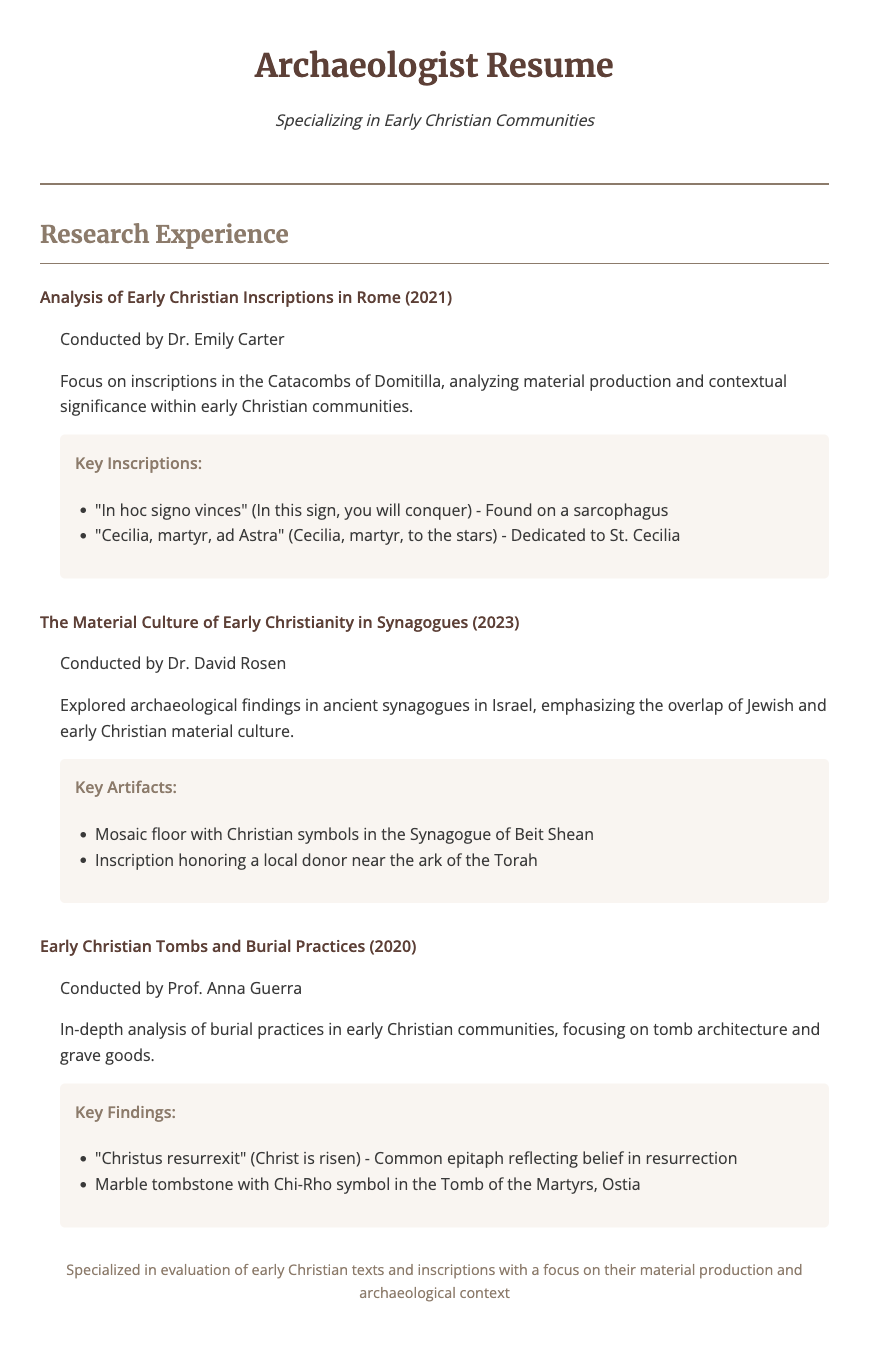what is the title of the research conducted in 2021? The title of the research is mentioned in the section on research experience, specifically stating "Analysis of Early Christian Inscriptions in Rome".
Answer: Analysis of Early Christian Inscriptions in Rome who conducted the research on the material culture of early Christianity in synagogues? The research on the material culture of early Christianity in synagogues was conducted by Dr. David Rosen.
Answer: Dr. David Rosen what is one of the key inscriptions found on a sarcophagus? The document mentions a specific inscription found on a sarcophagus that states "In hoc signo vinces".
Answer: In hoc signo vinces what year was the research on early Christian tombs conducted? The document specifies the research on early Christian tombs and burial practices was conducted in the year 2020.
Answer: 2020 which artifact included Christian symbols in ancient synagogues? The research item describes a "Mosaic floor with Christian symbols" found in the Synagogue of Beit Shean.
Answer: Mosaic floor with Christian symbols what common epitaph is mentioned regarding early Christian beliefs? The document notes that a common epitaph reflecting early Christian belief is "Christus resurrexit".
Answer: Christus resurrexit 